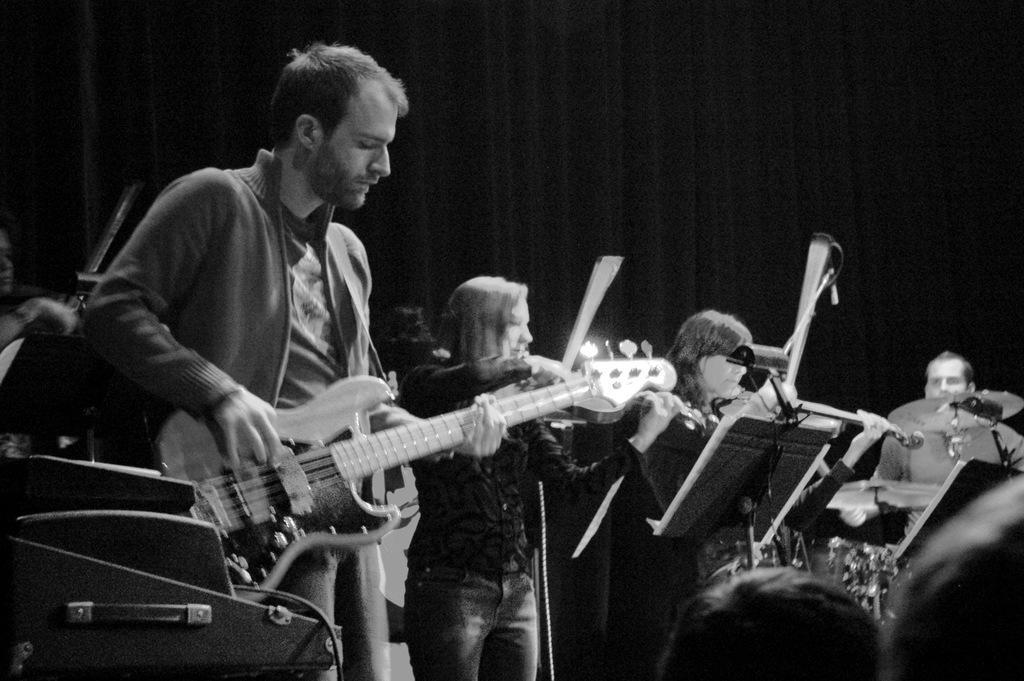Describe this image in one or two sentences. In the image we can see there are people who are standing and holding guitar in their hand and other musical instruments and the image is in black and white colour. 